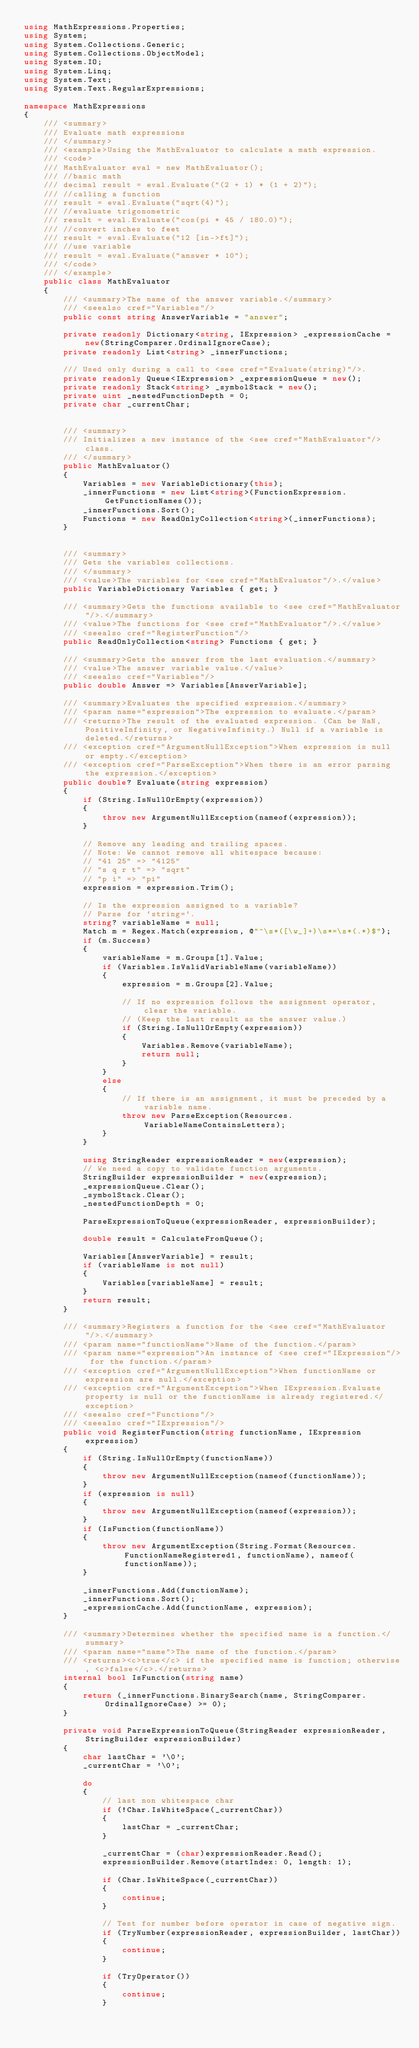<code> <loc_0><loc_0><loc_500><loc_500><_C#_>using MathExpressions.Properties;
using System;
using System.Collections.Generic;
using System.Collections.ObjectModel;
using System.IO;
using System.Linq;
using System.Text;
using System.Text.RegularExpressions;

namespace MathExpressions
{
	/// <summary>
	/// Evaluate math expressions
	/// </summary>
	/// <example>Using the MathEvaluator to calculate a math expression.
	/// <code>
	/// MathEvaluator eval = new MathEvaluator();
	/// //basic math
	/// decimal result = eval.Evaluate("(2 + 1) * (1 + 2)");
	/// //calling a function
	/// result = eval.Evaluate("sqrt(4)");
	/// //evaluate trigonometric 
	/// result = eval.Evaluate("cos(pi * 45 / 180.0)");
	/// //convert inches to feet
	/// result = eval.Evaluate("12 [in->ft]");
	/// //use variable
	/// result = eval.Evaluate("answer * 10");
	/// </code>
	/// </example>
	public class MathEvaluator
	{
		/// <summary>The name of the answer variable.</summary>
		/// <seealso cref="Variables"/>
		public const string AnswerVariable = "answer";

		private readonly Dictionary<string, IExpression> _expressionCache = new(StringComparer.OrdinalIgnoreCase);
		private readonly List<string> _innerFunctions;

		/// Used only during a call to <see	cref="Evaluate(string)"/>.
		private readonly Queue<IExpression> _expressionQueue = new();
		private readonly Stack<string> _symbolStack = new();
		private uint _nestedFunctionDepth = 0;
		private char _currentChar;


		/// <summary>
		/// Initializes a new instance of the <see cref="MathEvaluator"/> class.
		/// </summary>
		public MathEvaluator()
		{
			Variables = new VariableDictionary(this);
			_innerFunctions = new List<string>(FunctionExpression.GetFunctionNames());
			_innerFunctions.Sort();
			Functions = new ReadOnlyCollection<string>(_innerFunctions);
		}


		/// <summary>
		/// Gets the variables collections.
		/// </summary>
		/// <value>The variables for <see cref="MathEvaluator"/>.</value>
		public VariableDictionary Variables { get; }

		/// <summary>Gets the functions available to <see cref="MathEvaluator"/>.</summary>
		/// <value>The functions for <see cref="MathEvaluator"/>.</value>
		/// <seealso cref="RegisterFunction"/>
		public ReadOnlyCollection<string> Functions { get; }

		/// <summary>Gets the answer from the last evaluation.</summary>
		/// <value>The answer variable value.</value>
		/// <seealso cref="Variables"/>
		public double Answer => Variables[AnswerVariable];

		/// <summary>Evaluates the specified expression.</summary>
		/// <param name="expression">The expression to evaluate.</param>
		/// <returns>The result of the evaluated expression. (Can be NaN, PositiveInfinity, or NegativeInfinity.) Null if a variable is deleted.</returns>
		/// <exception cref="ArgumentNullException">When expression is null or empty.</exception>
		/// <exception cref="ParseException">When there is an error parsing the expression.</exception>
		public double? Evaluate(string expression)
		{
			if (String.IsNullOrEmpty(expression))
			{
				throw new ArgumentNullException(nameof(expression));
			}

			// Remove any leading and trailing spaces.
			// Note: We cannot remove all whitespace because:
			// "41 25" => "4125"
			// "s q r t" => "sqrt"
			// "p i" => "pi"
			expression = expression.Trim();

			// Is the expression assigned to a variable?
			// Parse for `string=`.
			string? variableName = null;
			Match m = Regex.Match(expression, @"^\s*([\w_]+)\s*=\s*(.*)$");
			if (m.Success)
			{
				variableName = m.Groups[1].Value;
				if (Variables.IsValidVariableName(variableName))
				{
					expression = m.Groups[2].Value;

					// If no expression follows the assignment operator, clear the variable.
					// (Keep the last result as the answer value.)
					if (String.IsNullOrEmpty(expression))
					{
						Variables.Remove(variableName);
						return null;
					}
				}
				else
				{
					// If there is an assignment, it must be preceded by a variable name.
					throw new ParseException(Resources.VariableNameContainsLetters);
				}
			}

			using StringReader expressionReader = new(expression);
			// We need a copy to validate function arguments.
			StringBuilder expressionBuilder = new(expression);
			_expressionQueue.Clear();
			_symbolStack.Clear();
			_nestedFunctionDepth = 0;

			ParseExpressionToQueue(expressionReader, expressionBuilder);

			double result = CalculateFromQueue();

			Variables[AnswerVariable] = result;
			if (variableName is not null)
			{
				Variables[variableName] = result;
			}
			return result;
		}

		/// <summary>Registers a function for the <see cref="MathEvaluator"/>.</summary>
		/// <param name="functionName">Name of the function.</param>
		/// <param name="expression">An instance of <see cref="IExpression"/> for the function.</param>
		/// <exception cref="ArgumentNullException">When functionName or expression are null.</exception>
		/// <exception cref="ArgumentException">When IExpression.Evaluate property is null or the functionName is already registered.</exception>
		/// <seealso cref="Functions"/>
		/// <seealso cref="IExpression"/>
		public void RegisterFunction(string functionName, IExpression expression)
		{
			if (String.IsNullOrEmpty(functionName))
			{
				throw new ArgumentNullException(nameof(functionName));
			}
			if (expression is null)
			{
				throw new ArgumentNullException(nameof(expression));
			}
			if (IsFunction(functionName))
			{
				throw new ArgumentException(String.Format(Resources.FunctionNameRegistered1, functionName), nameof(functionName));
			}

			_innerFunctions.Add(functionName);
			_innerFunctions.Sort();
			_expressionCache.Add(functionName, expression);
		}

		/// <summary>Determines whether the specified name is a function.</summary>
		/// <param name="name">The name of the function.</param>
		/// <returns><c>true</c> if the specified name is function; otherwise, <c>false</c>.</returns>
		internal bool IsFunction(string name)
		{
			return (_innerFunctions.BinarySearch(name, StringComparer.OrdinalIgnoreCase) >= 0);
		}

		private void ParseExpressionToQueue(StringReader expressionReader, StringBuilder expressionBuilder)
		{
			char lastChar = '\0';
			_currentChar = '\0';

			do
			{
				// last non whitespace char
				if (!Char.IsWhiteSpace(_currentChar))
				{
					lastChar = _currentChar;
				}

				_currentChar = (char)expressionReader.Read();
				expressionBuilder.Remove(startIndex: 0, length: 1);

				if (Char.IsWhiteSpace(_currentChar))
				{
					continue;
				}

				// Test for number before operator in case of negative sign.
				if (TryNumber(expressionReader, expressionBuilder, lastChar))
				{
					continue;
				}

				if (TryOperator())
				{
					continue;
				}
</code> 